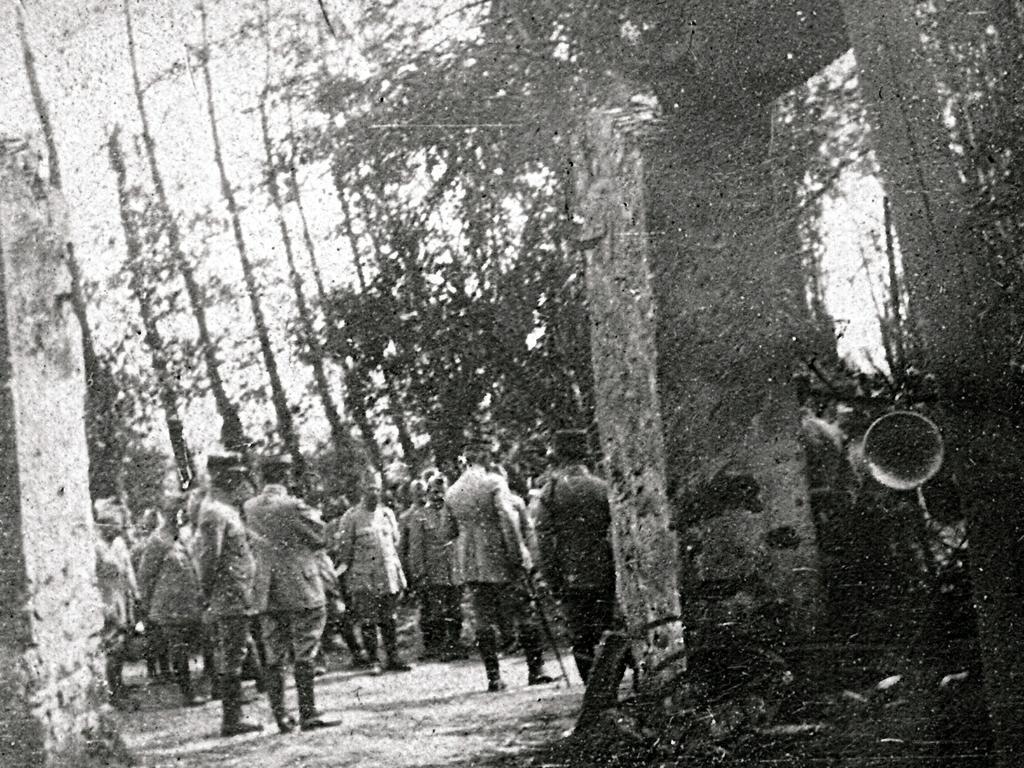Describe this image in one or two sentences. This is a black and white image. In this image we can see people standing on the ground wearing a uniform. In the background there are trees and pillars. 